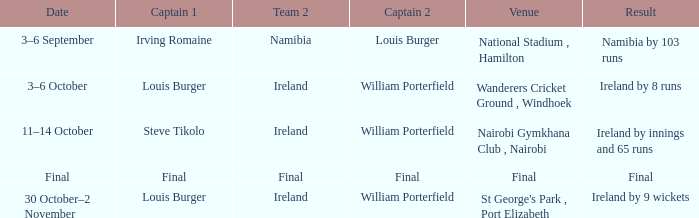In captain 2, who has the final result? Final. 